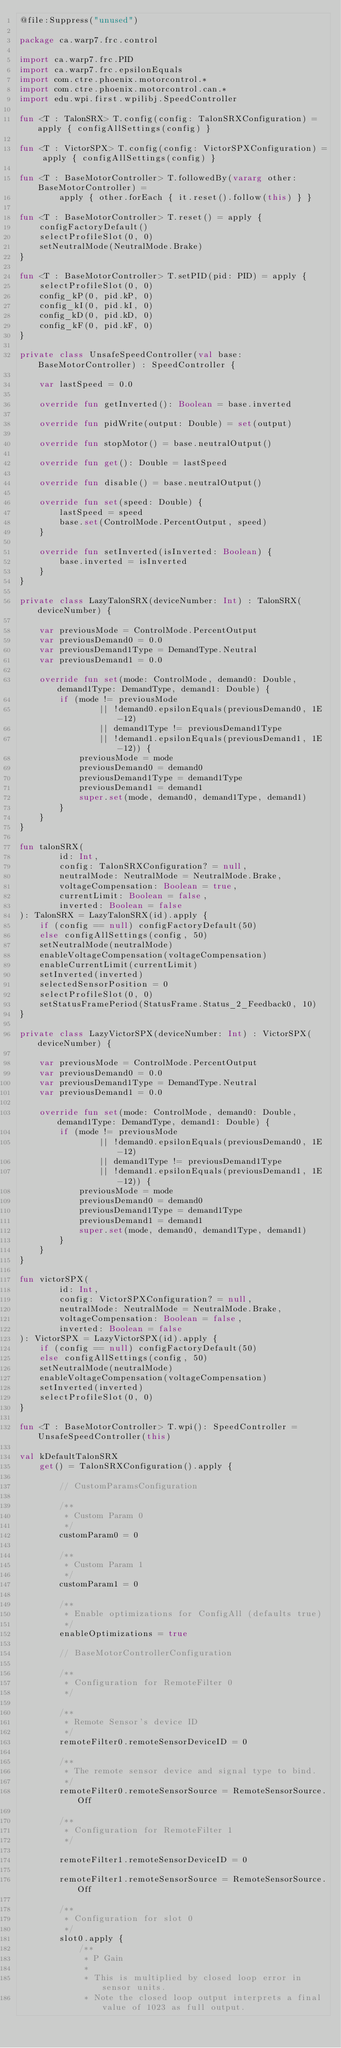<code> <loc_0><loc_0><loc_500><loc_500><_Kotlin_>@file:Suppress("unused")

package ca.warp7.frc.control

import ca.warp7.frc.PID
import ca.warp7.frc.epsilonEquals
import com.ctre.phoenix.motorcontrol.*
import com.ctre.phoenix.motorcontrol.can.*
import edu.wpi.first.wpilibj.SpeedController

fun <T : TalonSRX> T.config(config: TalonSRXConfiguration) = apply { configAllSettings(config) }

fun <T : VictorSPX> T.config(config: VictorSPXConfiguration) = apply { configAllSettings(config) }

fun <T : BaseMotorController> T.followedBy(vararg other: BaseMotorController) =
        apply { other.forEach { it.reset().follow(this) } }

fun <T : BaseMotorController> T.reset() = apply {
    configFactoryDefault()
    selectProfileSlot(0, 0)
    setNeutralMode(NeutralMode.Brake)
}

fun <T : BaseMotorController> T.setPID(pid: PID) = apply {
    selectProfileSlot(0, 0)
    config_kP(0, pid.kP, 0)
    config_kI(0, pid.kI, 0)
    config_kD(0, pid.kD, 0)
    config_kF(0, pid.kF, 0)
}

private class UnsafeSpeedController(val base: BaseMotorController) : SpeedController {

    var lastSpeed = 0.0

    override fun getInverted(): Boolean = base.inverted

    override fun pidWrite(output: Double) = set(output)

    override fun stopMotor() = base.neutralOutput()

    override fun get(): Double = lastSpeed

    override fun disable() = base.neutralOutput()

    override fun set(speed: Double) {
        lastSpeed = speed
        base.set(ControlMode.PercentOutput, speed)
    }

    override fun setInverted(isInverted: Boolean) {
        base.inverted = isInverted
    }
}

private class LazyTalonSRX(deviceNumber: Int) : TalonSRX(deviceNumber) {

    var previousMode = ControlMode.PercentOutput
    var previousDemand0 = 0.0
    var previousDemand1Type = DemandType.Neutral
    var previousDemand1 = 0.0

    override fun set(mode: ControlMode, demand0: Double, demand1Type: DemandType, demand1: Double) {
        if (mode != previousMode
                || !demand0.epsilonEquals(previousDemand0, 1E-12)
                || demand1Type != previousDemand1Type
                || !demand1.epsilonEquals(previousDemand1, 1E-12)) {
            previousMode = mode
            previousDemand0 = demand0
            previousDemand1Type = demand1Type
            previousDemand1 = demand1
            super.set(mode, demand0, demand1Type, demand1)
        }
    }
}

fun talonSRX(
        id: Int,
        config: TalonSRXConfiguration? = null,
        neutralMode: NeutralMode = NeutralMode.Brake,
        voltageCompensation: Boolean = true,
        currentLimit: Boolean = false,
        inverted: Boolean = false
): TalonSRX = LazyTalonSRX(id).apply {
    if (config == null) configFactoryDefault(50)
    else configAllSettings(config, 50)
    setNeutralMode(neutralMode)
    enableVoltageCompensation(voltageCompensation)
    enableCurrentLimit(currentLimit)
    setInverted(inverted)
    selectedSensorPosition = 0
    selectProfileSlot(0, 0)
    setStatusFramePeriod(StatusFrame.Status_2_Feedback0, 10)
}

private class LazyVictorSPX(deviceNumber: Int) : VictorSPX(deviceNumber) {

    var previousMode = ControlMode.PercentOutput
    var previousDemand0 = 0.0
    var previousDemand1Type = DemandType.Neutral
    var previousDemand1 = 0.0

    override fun set(mode: ControlMode, demand0: Double, demand1Type: DemandType, demand1: Double) {
        if (mode != previousMode
                || !demand0.epsilonEquals(previousDemand0, 1E-12)
                || demand1Type != previousDemand1Type
                || !demand1.epsilonEquals(previousDemand1, 1E-12)) {
            previousMode = mode
            previousDemand0 = demand0
            previousDemand1Type = demand1Type
            previousDemand1 = demand1
            super.set(mode, demand0, demand1Type, demand1)
        }
    }
}

fun victorSPX(
        id: Int,
        config: VictorSPXConfiguration? = null,
        neutralMode: NeutralMode = NeutralMode.Brake,
        voltageCompensation: Boolean = false,
        inverted: Boolean = false
): VictorSPX = LazyVictorSPX(id).apply {
    if (config == null) configFactoryDefault(50)
    else configAllSettings(config, 50)
    setNeutralMode(neutralMode)
    enableVoltageCompensation(voltageCompensation)
    setInverted(inverted)
    selectProfileSlot(0, 0)
}

fun <T : BaseMotorController> T.wpi(): SpeedController = UnsafeSpeedController(this)

val kDefaultTalonSRX
    get() = TalonSRXConfiguration().apply {

        // CustomParamsConfiguration

        /**
         * Custom Param 0
         */
        customParam0 = 0

        /**
         * Custom Param 1
         */
        customParam1 = 0

        /**
         * Enable optimizations for ConfigAll (defaults true)
         */
        enableOptimizations = true

        // BaseMotorControllerConfiguration

        /**
         * Configuration for RemoteFilter 0
         */

        /**
         * Remote Sensor's device ID
         */
        remoteFilter0.remoteSensorDeviceID = 0

        /**
         * The remote sensor device and signal type to bind.
         */
        remoteFilter0.remoteSensorSource = RemoteSensorSource.Off

        /**
         * Configuration for RemoteFilter 1
         */

        remoteFilter1.remoteSensorDeviceID = 0

        remoteFilter1.remoteSensorSource = RemoteSensorSource.Off

        /**
         * Configuration for slot 0
         */
        slot0.apply {
            /**
             * P Gain
             *
             * This is multiplied by closed loop error in sensor units.
             * Note the closed loop output interprets a final value of 1023 as full output.</code> 